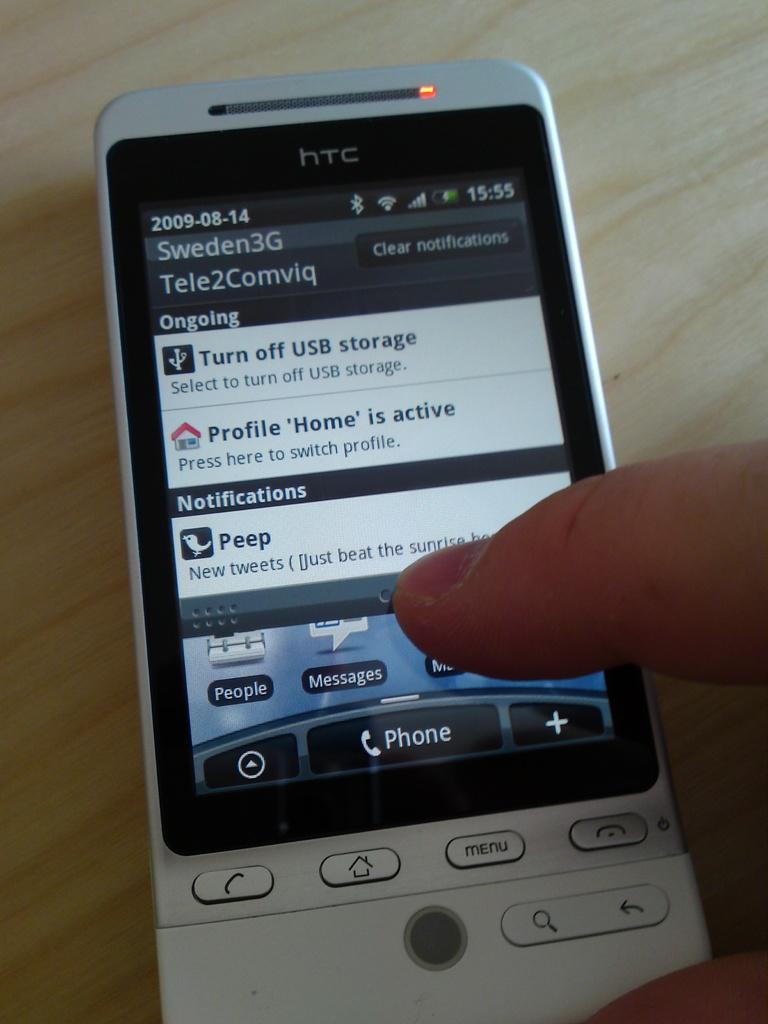<image>
Create a compact narrative representing the image presented. A person using their thumb to tap on a htc cellphone. 